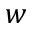<formula> <loc_0><loc_0><loc_500><loc_500>w</formula> 